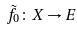<formula> <loc_0><loc_0><loc_500><loc_500>\tilde { f } _ { 0 } \colon X \rightarrow E</formula> 